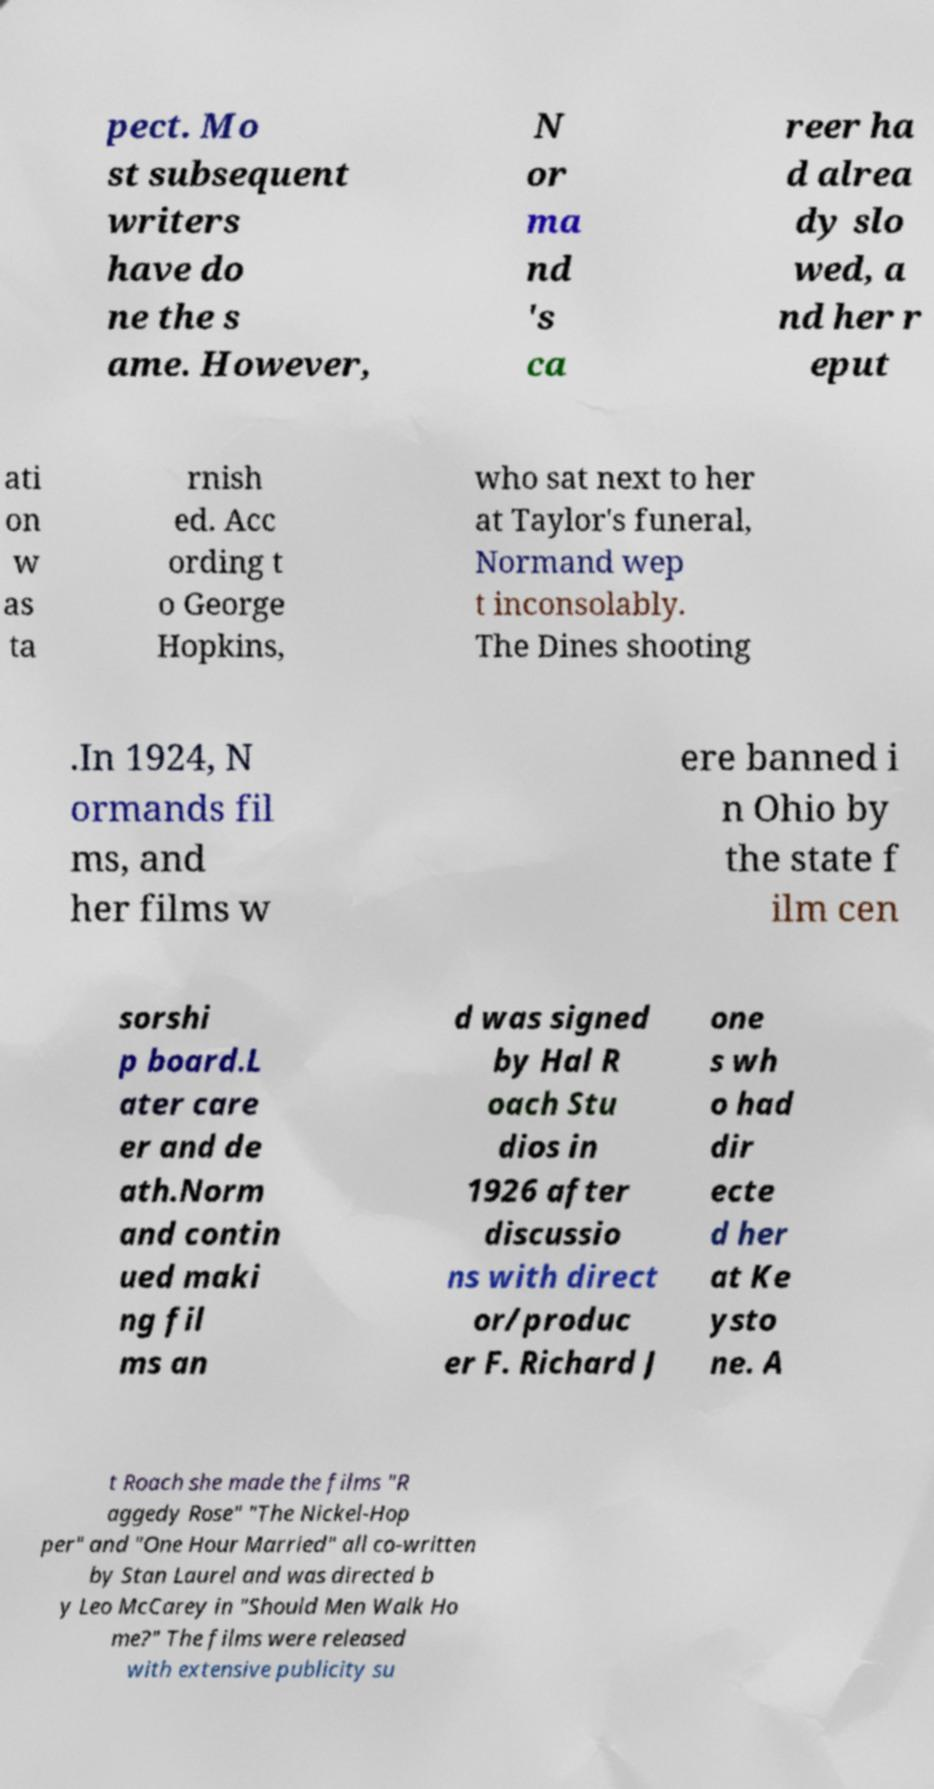Could you assist in decoding the text presented in this image and type it out clearly? pect. Mo st subsequent writers have do ne the s ame. However, N or ma nd 's ca reer ha d alrea dy slo wed, a nd her r eput ati on w as ta rnish ed. Acc ording t o George Hopkins, who sat next to her at Taylor's funeral, Normand wep t inconsolably. The Dines shooting .In 1924, N ormands fil ms, and her films w ere banned i n Ohio by the state f ilm cen sorshi p board.L ater care er and de ath.Norm and contin ued maki ng fil ms an d was signed by Hal R oach Stu dios in 1926 after discussio ns with direct or/produc er F. Richard J one s wh o had dir ecte d her at Ke ysto ne. A t Roach she made the films "R aggedy Rose" "The Nickel-Hop per" and "One Hour Married" all co-written by Stan Laurel and was directed b y Leo McCarey in "Should Men Walk Ho me?" The films were released with extensive publicity su 